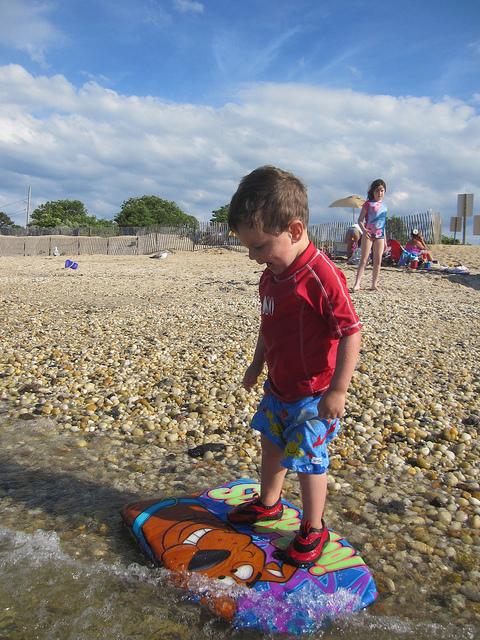What is on his left wrist?
Answer briefly. Nothing. What is the kid standing on?
Short answer required. Boogie board. Is the boy by the water?
Answer briefly. Yes. Are there any fish in the water?
Keep it brief. No. What is this person riding?
Quick response, please. Boogie board. Is there grass in the image?
Keep it brief. No. Does the small person's shirt have buttons?
Keep it brief. No. Is the sun to the left or to the right of the boy?
Short answer required. Right. What is the color of the boy shoes?
Write a very short answer. Red. What is in the sky?
Keep it brief. Clouds. Is this little boy wearing a red shirt?
Give a very brief answer. Yes. Is there a large rock behind the boy?
Write a very short answer. No. What color are the tree's leaves?
Short answer required. Green. 